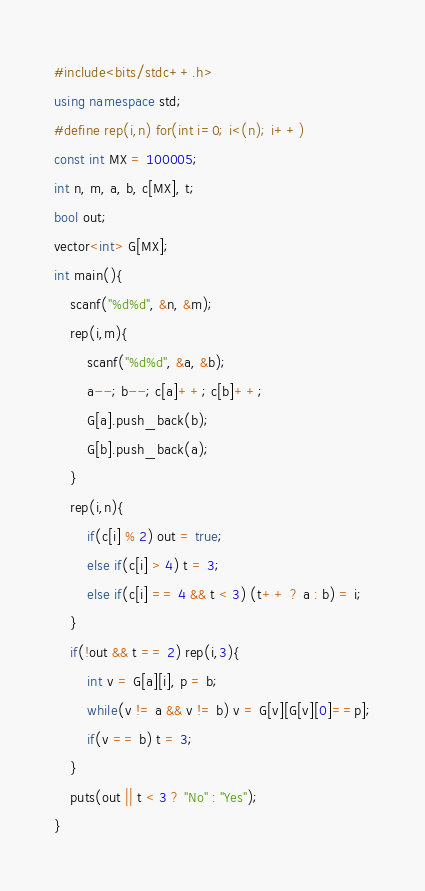Convert code to text. <code><loc_0><loc_0><loc_500><loc_500><_C++_>#include<bits/stdc++.h>
using namespace std;
#define rep(i,n) for(int i=0; i<(n); i++)
const int MX = 100005;
int n, m, a, b, c[MX], t;
bool out;
vector<int> G[MX];
int main(){
	scanf("%d%d", &n, &m);
	rep(i,m){
		scanf("%d%d", &a, &b);
		a--; b--; c[a]++; c[b]++;
		G[a].push_back(b);
		G[b].push_back(a);
	}
	rep(i,n){
		if(c[i] % 2) out = true;
		else if(c[i] > 4) t = 3;
		else if(c[i] == 4 && t < 3) (t++ ? a : b) = i;
	}
	if(!out && t == 2) rep(i,3){
		int v = G[a][i], p = b;
		while(v != a && v != b) v = G[v][G[v][0]==p];
		if(v == b) t = 3;
	}
	puts(out || t < 3 ? "No" : "Yes");
}</code> 